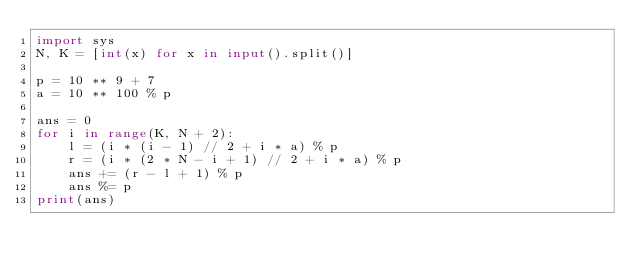Convert code to text. <code><loc_0><loc_0><loc_500><loc_500><_Python_>import sys
N, K = [int(x) for x in input().split()]

p = 10 ** 9 + 7
a = 10 ** 100 % p

ans = 0
for i in range(K, N + 2):
    l = (i * (i - 1) // 2 + i * a) % p
    r = (i * (2 * N - i + 1) // 2 + i * a) % p
    ans += (r - l + 1) % p
    ans %= p
print(ans)</code> 